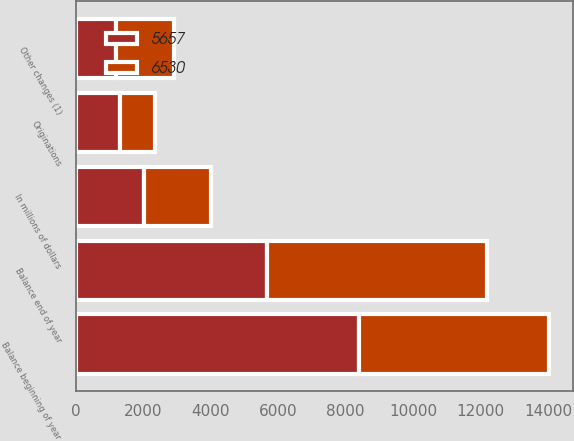<chart> <loc_0><loc_0><loc_500><loc_500><stacked_bar_chart><ecel><fcel>In millions of dollars<fcel>Balance beginning of year<fcel>Originations<fcel>Other changes (1)<fcel>Balance end of year<nl><fcel>6530<fcel>2009<fcel>5657<fcel>1035<fcel>1708<fcel>6530<nl><fcel>5657<fcel>2008<fcel>8380<fcel>1311<fcel>1190<fcel>5657<nl></chart> 